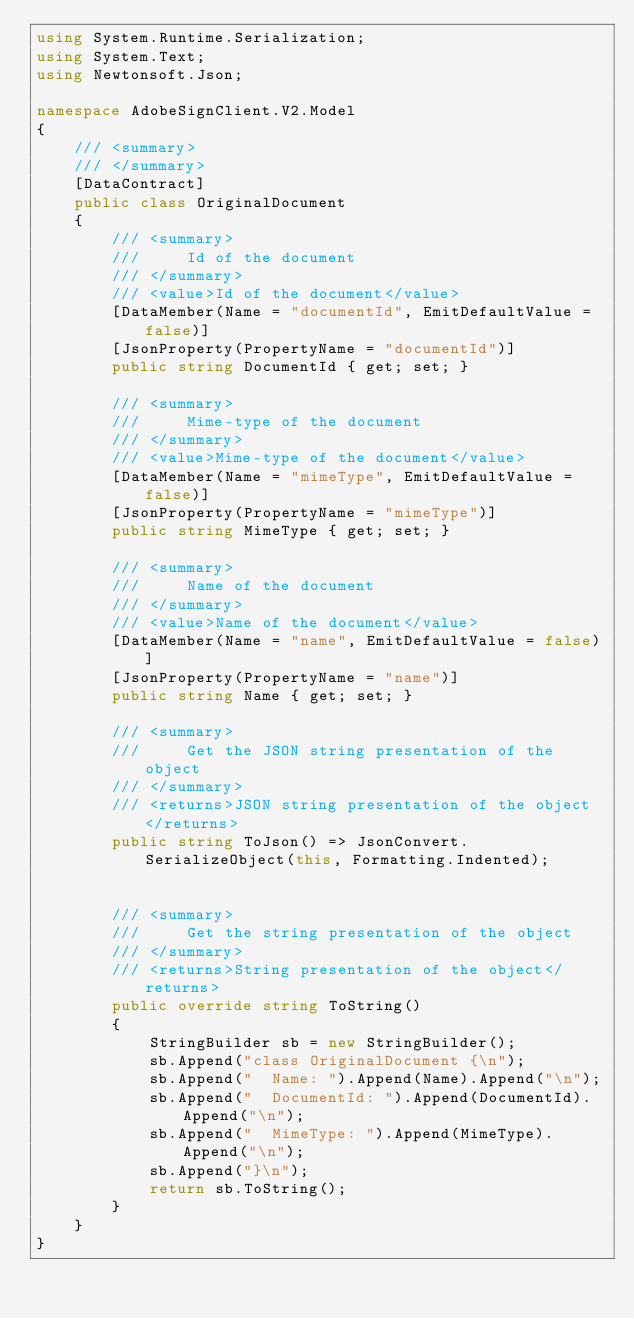<code> <loc_0><loc_0><loc_500><loc_500><_C#_>using System.Runtime.Serialization;
using System.Text;
using Newtonsoft.Json;

namespace AdobeSignClient.V2.Model
{
    /// <summary>
    /// </summary>
    [DataContract]
    public class OriginalDocument
    {
        /// <summary>
        ///     Id of the document
        /// </summary>
        /// <value>Id of the document</value>
        [DataMember(Name = "documentId", EmitDefaultValue = false)]
        [JsonProperty(PropertyName = "documentId")]
        public string DocumentId { get; set; }

        /// <summary>
        ///     Mime-type of the document
        /// </summary>
        /// <value>Mime-type of the document</value>
        [DataMember(Name = "mimeType", EmitDefaultValue = false)]
        [JsonProperty(PropertyName = "mimeType")]
        public string MimeType { get; set; }

        /// <summary>
        ///     Name of the document
        /// </summary>
        /// <value>Name of the document</value>
        [DataMember(Name = "name", EmitDefaultValue = false)]
        [JsonProperty(PropertyName = "name")]
        public string Name { get; set; }

        /// <summary>
        ///     Get the JSON string presentation of the object
        /// </summary>
        /// <returns>JSON string presentation of the object</returns>
        public string ToJson() => JsonConvert.SerializeObject(this, Formatting.Indented);


        /// <summary>
        ///     Get the string presentation of the object
        /// </summary>
        /// <returns>String presentation of the object</returns>
        public override string ToString()
        {
            StringBuilder sb = new StringBuilder();
            sb.Append("class OriginalDocument {\n");
            sb.Append("  Name: ").Append(Name).Append("\n");
            sb.Append("  DocumentId: ").Append(DocumentId).Append("\n");
            sb.Append("  MimeType: ").Append(MimeType).Append("\n");
            sb.Append("}\n");
            return sb.ToString();
        }
    }
}</code> 